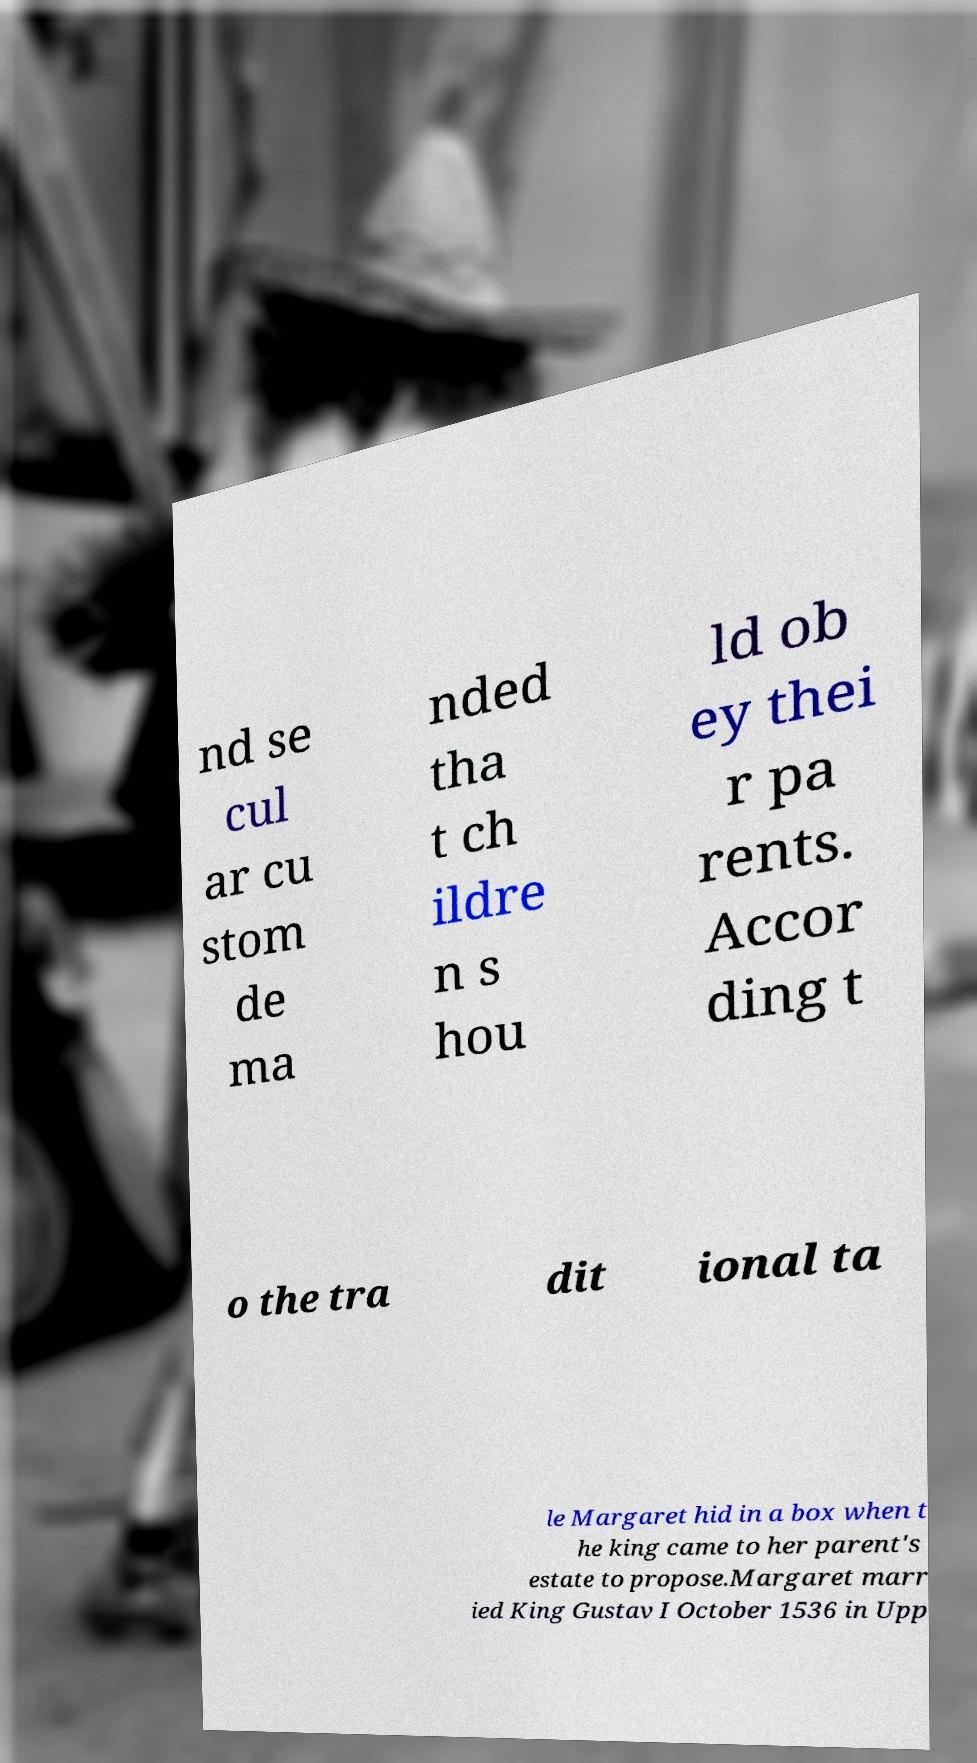There's text embedded in this image that I need extracted. Can you transcribe it verbatim? nd se cul ar cu stom de ma nded tha t ch ildre n s hou ld ob ey thei r pa rents. Accor ding t o the tra dit ional ta le Margaret hid in a box when t he king came to her parent's estate to propose.Margaret marr ied King Gustav I October 1536 in Upp 